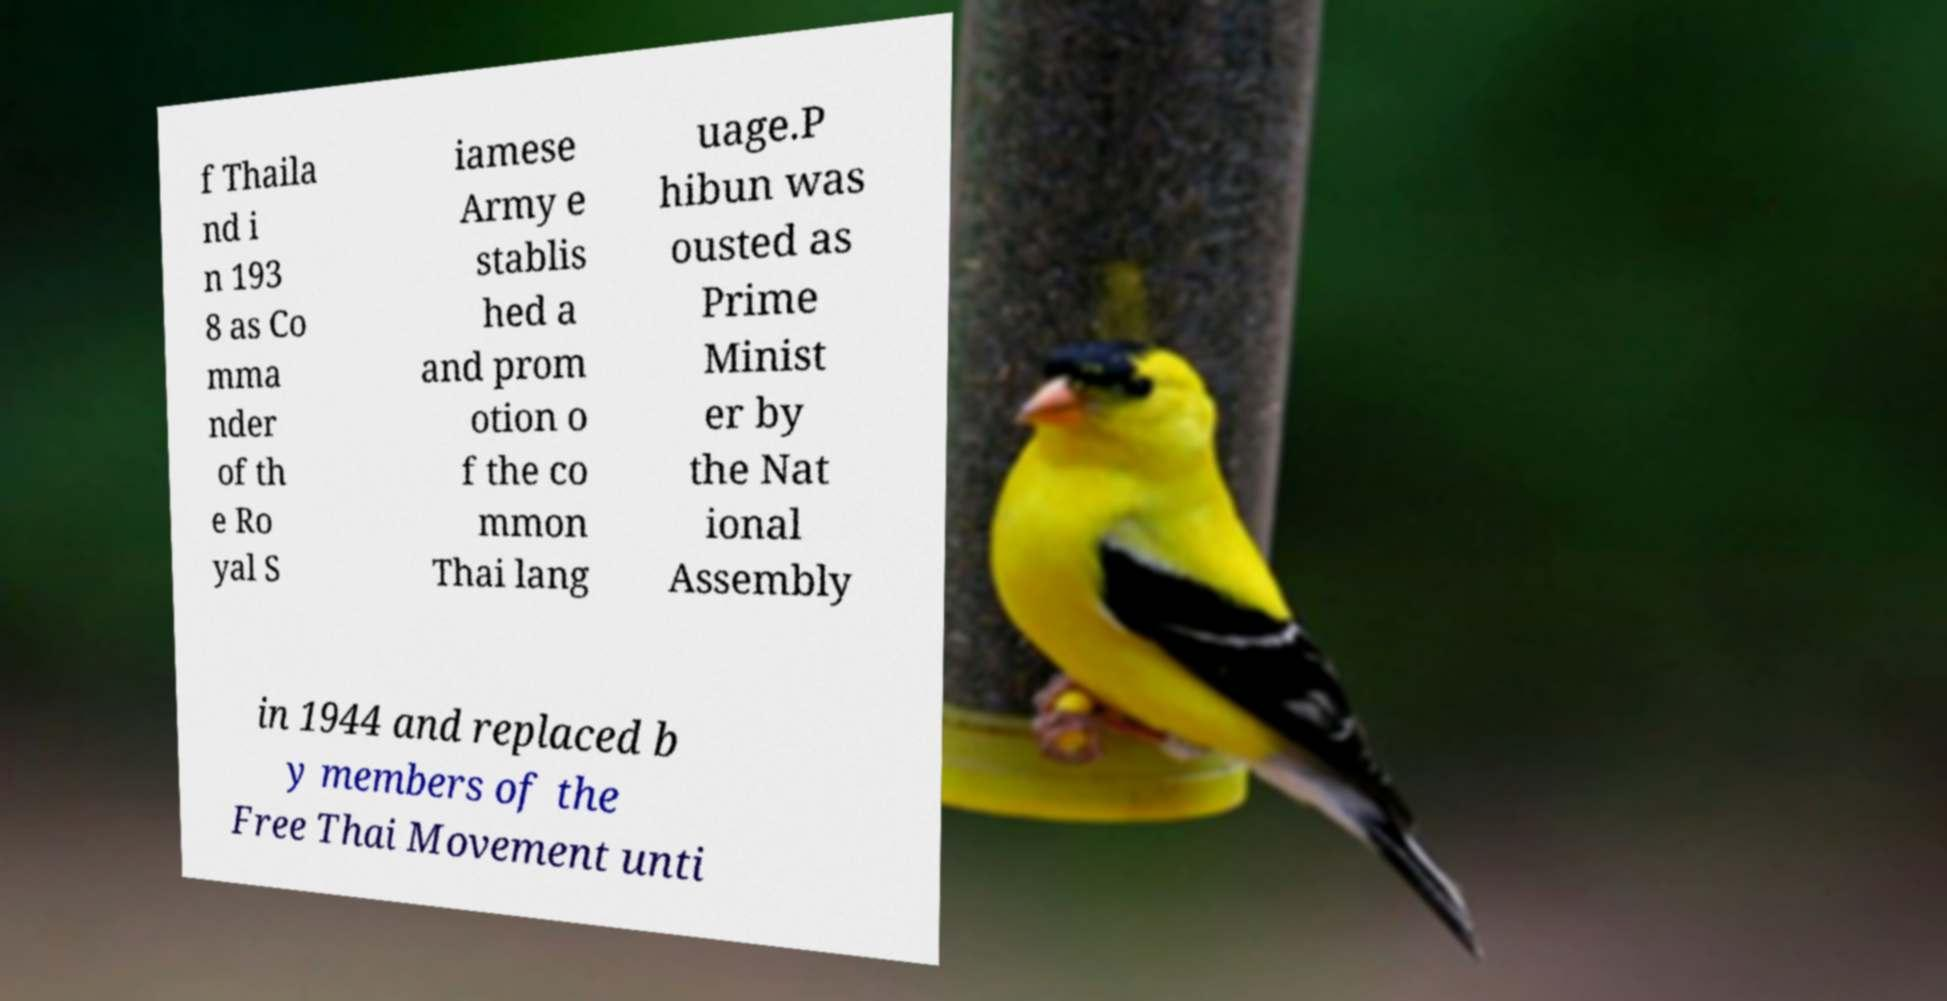I need the written content from this picture converted into text. Can you do that? f Thaila nd i n 193 8 as Co mma nder of th e Ro yal S iamese Army e stablis hed a and prom otion o f the co mmon Thai lang uage.P hibun was ousted as Prime Minist er by the Nat ional Assembly in 1944 and replaced b y members of the Free Thai Movement unti 